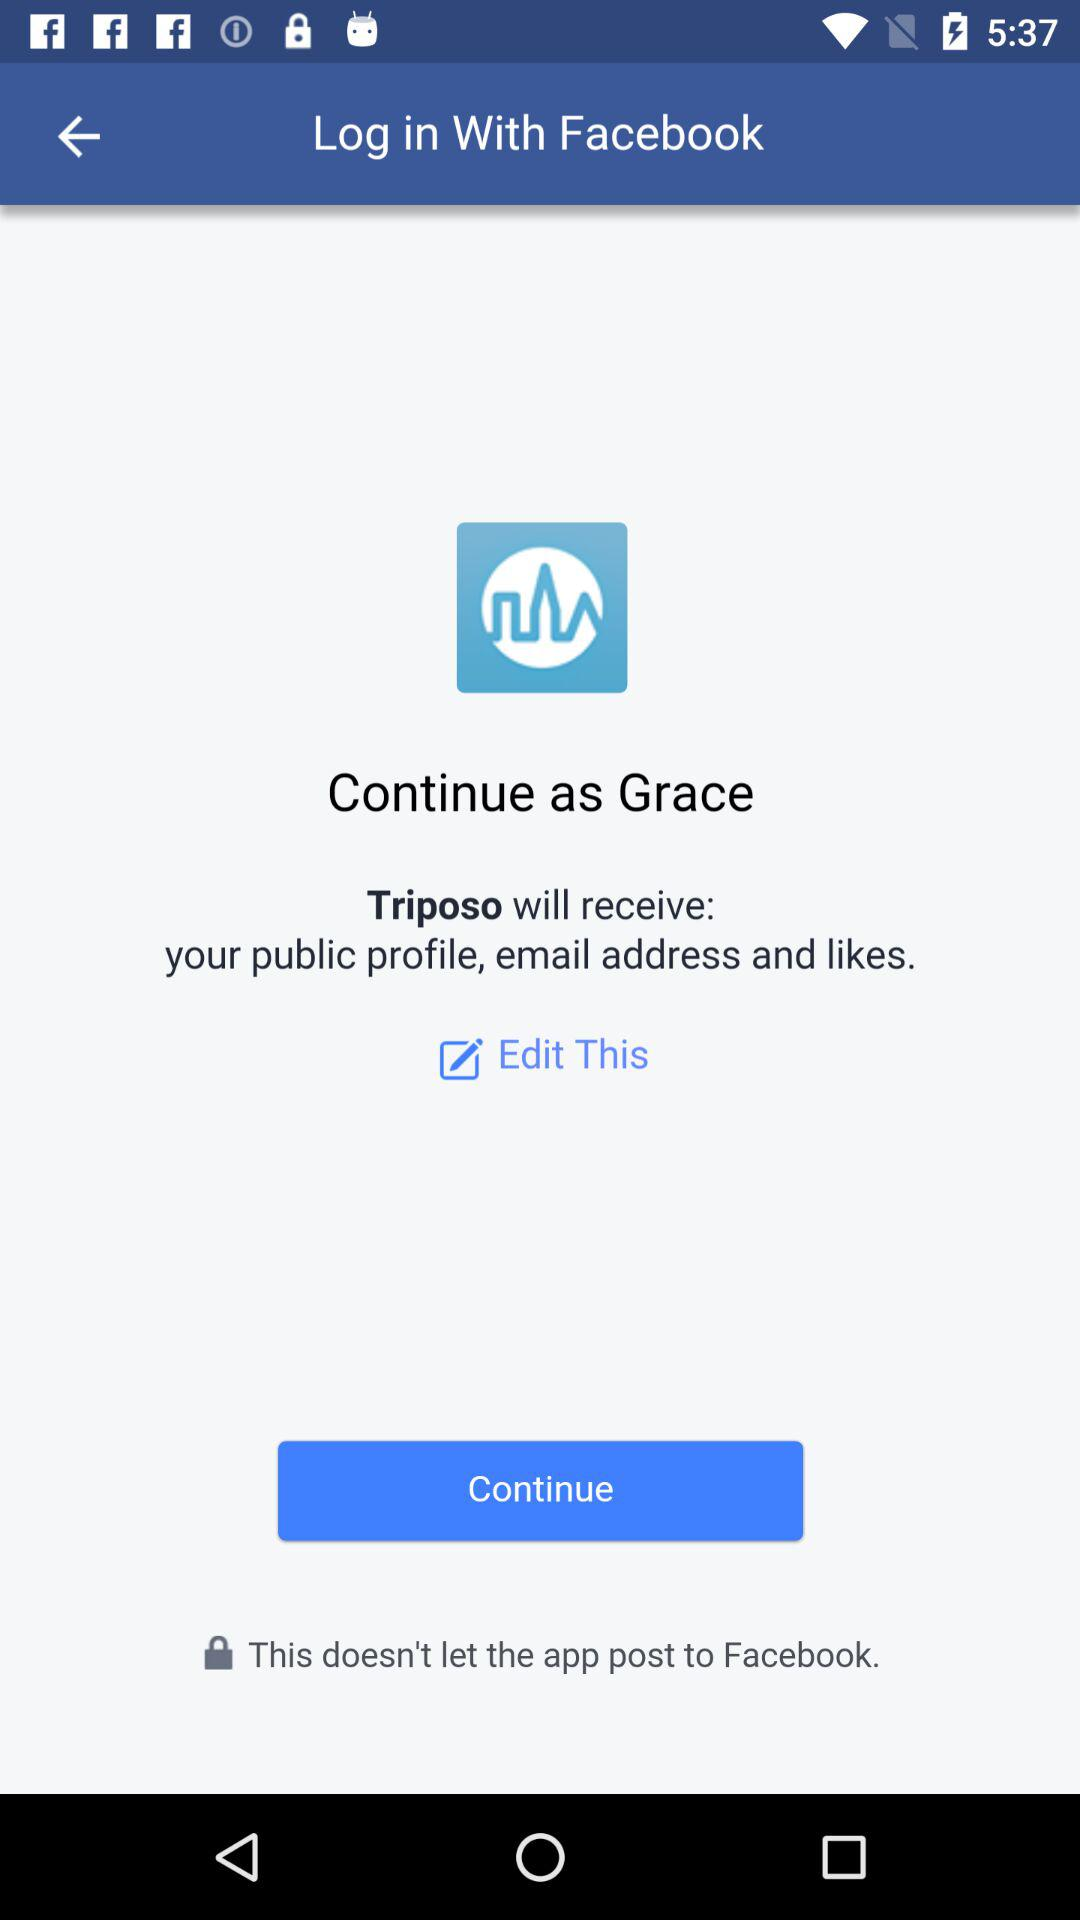What is the login name? The login name is "Grace". 